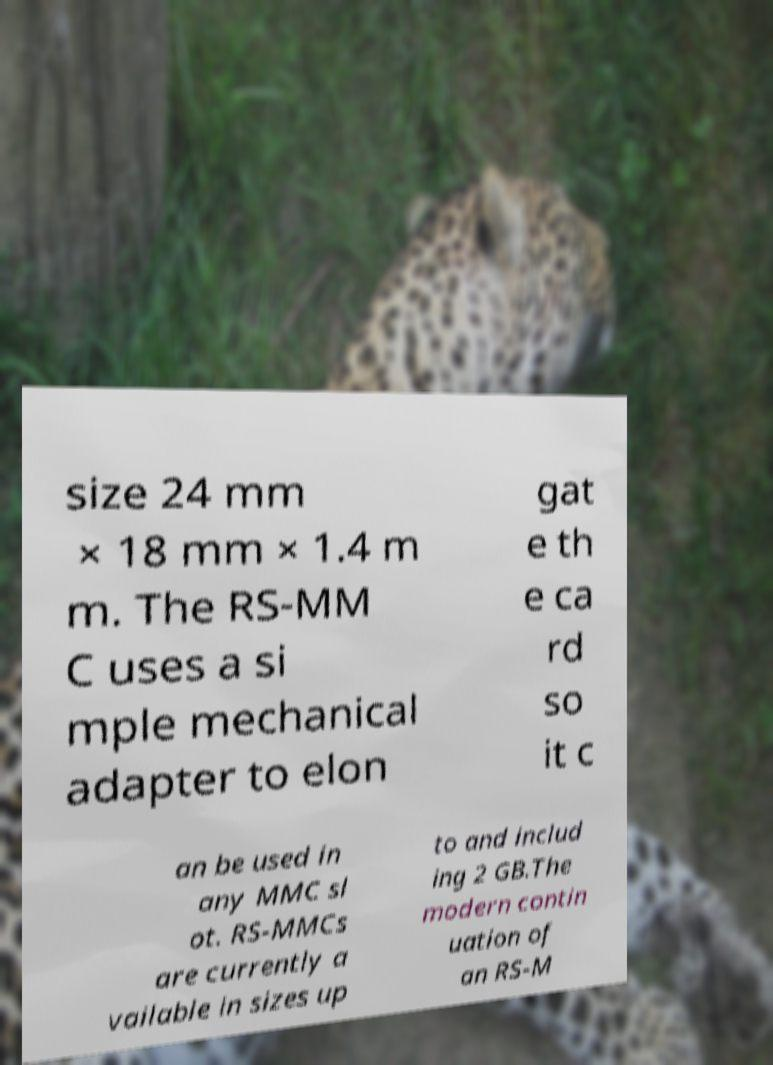Can you read and provide the text displayed in the image?This photo seems to have some interesting text. Can you extract and type it out for me? size 24 mm × 18 mm × 1.4 m m. The RS-MM C uses a si mple mechanical adapter to elon gat e th e ca rd so it c an be used in any MMC sl ot. RS-MMCs are currently a vailable in sizes up to and includ ing 2 GB.The modern contin uation of an RS-M 